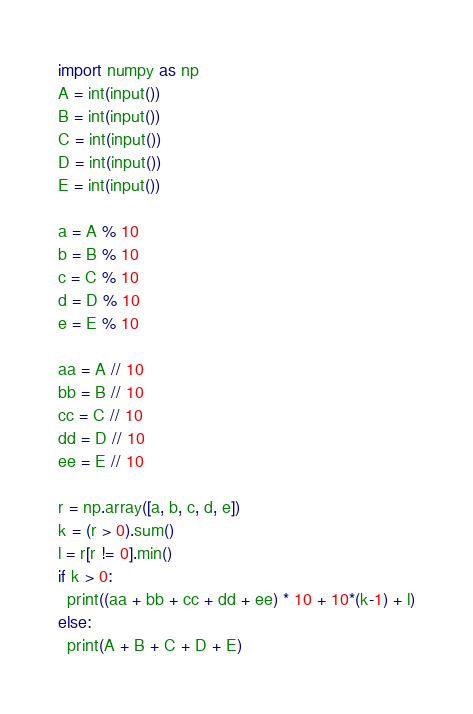<code> <loc_0><loc_0><loc_500><loc_500><_Python_>import numpy as np
A = int(input())
B = int(input())
C = int(input())
D = int(input())
E = int(input())
 
a = A % 10
b = B % 10
c = C % 10
d = D % 10
e = E % 10

aa = A // 10
bb = B // 10
cc = C // 10
dd = D // 10
ee = E // 10
 
r = np.array([a, b, c, d, e])
k = (r > 0).sum()
l = r[r != 0].min()
if k > 0:
  print((aa + bb + cc + dd + ee) * 10 + 10*(k-1) + l)
else:
  print(A + B + C + D + E)</code> 